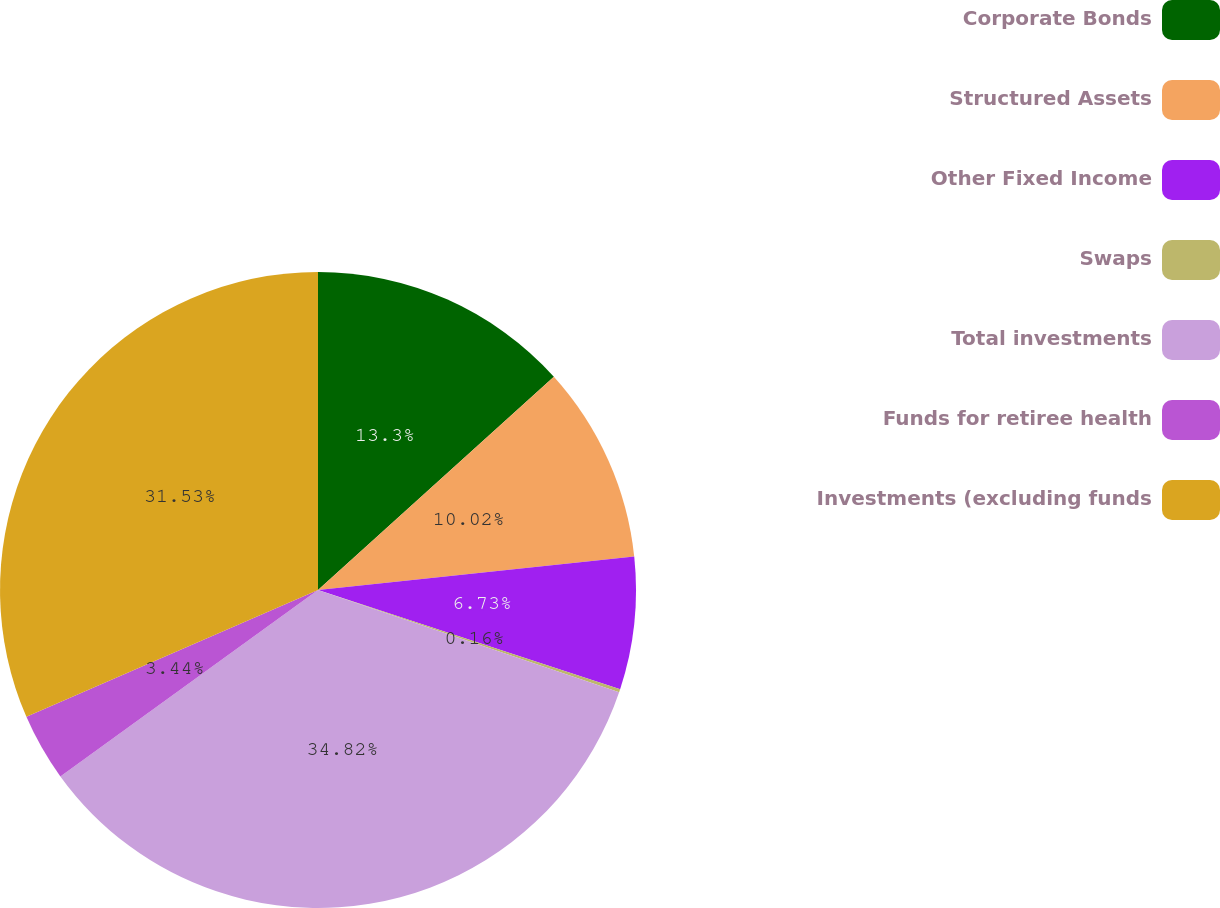Convert chart. <chart><loc_0><loc_0><loc_500><loc_500><pie_chart><fcel>Corporate Bonds<fcel>Structured Assets<fcel>Other Fixed Income<fcel>Swaps<fcel>Total investments<fcel>Funds for retiree health<fcel>Investments (excluding funds<nl><fcel>13.3%<fcel>10.02%<fcel>6.73%<fcel>0.16%<fcel>34.82%<fcel>3.44%<fcel>31.53%<nl></chart> 